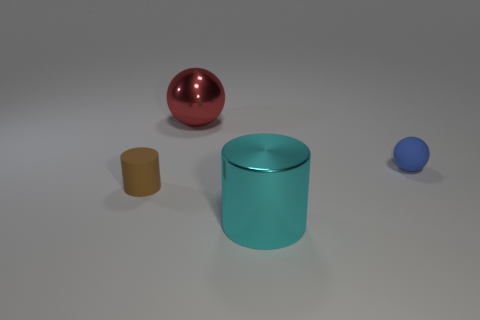Add 1 big metal cylinders. How many objects exist? 5 Subtract 2 spheres. How many spheres are left? 0 Subtract all cyan cylinders. How many cylinders are left? 1 Add 1 red balls. How many red balls are left? 2 Add 3 tiny yellow metallic cylinders. How many tiny yellow metallic cylinders exist? 3 Subtract 1 cyan cylinders. How many objects are left? 3 Subtract all brown balls. Subtract all yellow cylinders. How many balls are left? 2 Subtract all yellow spheres. How many cyan cylinders are left? 1 Subtract all red objects. Subtract all red cubes. How many objects are left? 3 